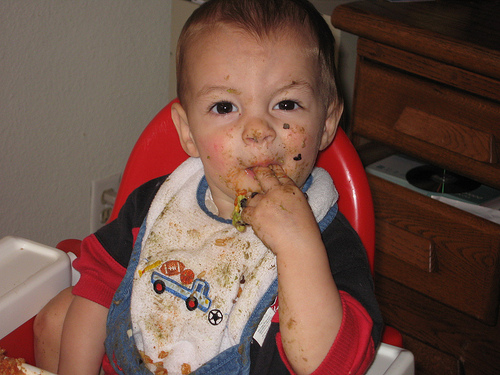<image>
Is there a bib on the baby? Yes. Looking at the image, I can see the bib is positioned on top of the baby, with the baby providing support. Where is the cd in relation to the box? Is it on the box? Yes. Looking at the image, I can see the cd is positioned on top of the box, with the box providing support. 